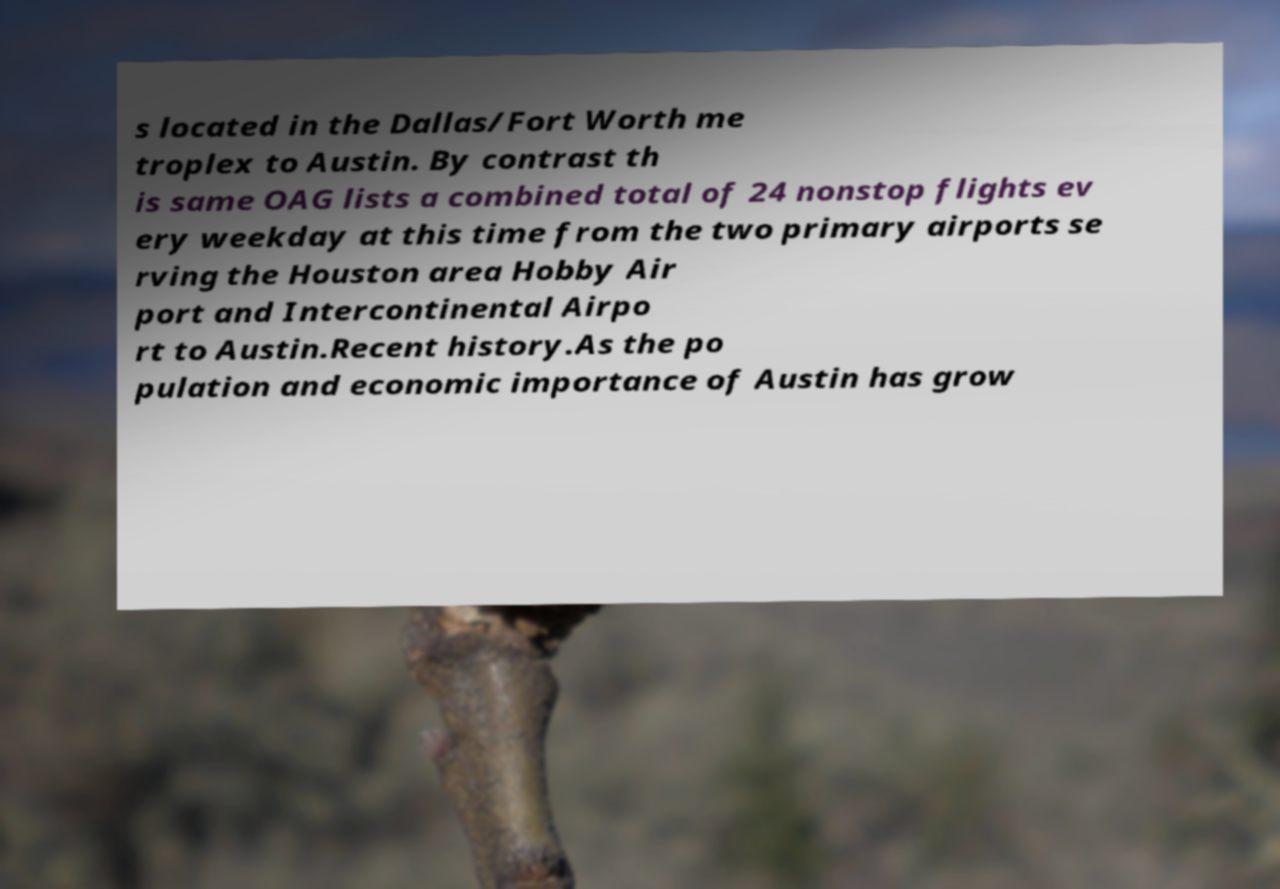For documentation purposes, I need the text within this image transcribed. Could you provide that? s located in the Dallas/Fort Worth me troplex to Austin. By contrast th is same OAG lists a combined total of 24 nonstop flights ev ery weekday at this time from the two primary airports se rving the Houston area Hobby Air port and Intercontinental Airpo rt to Austin.Recent history.As the po pulation and economic importance of Austin has grow 